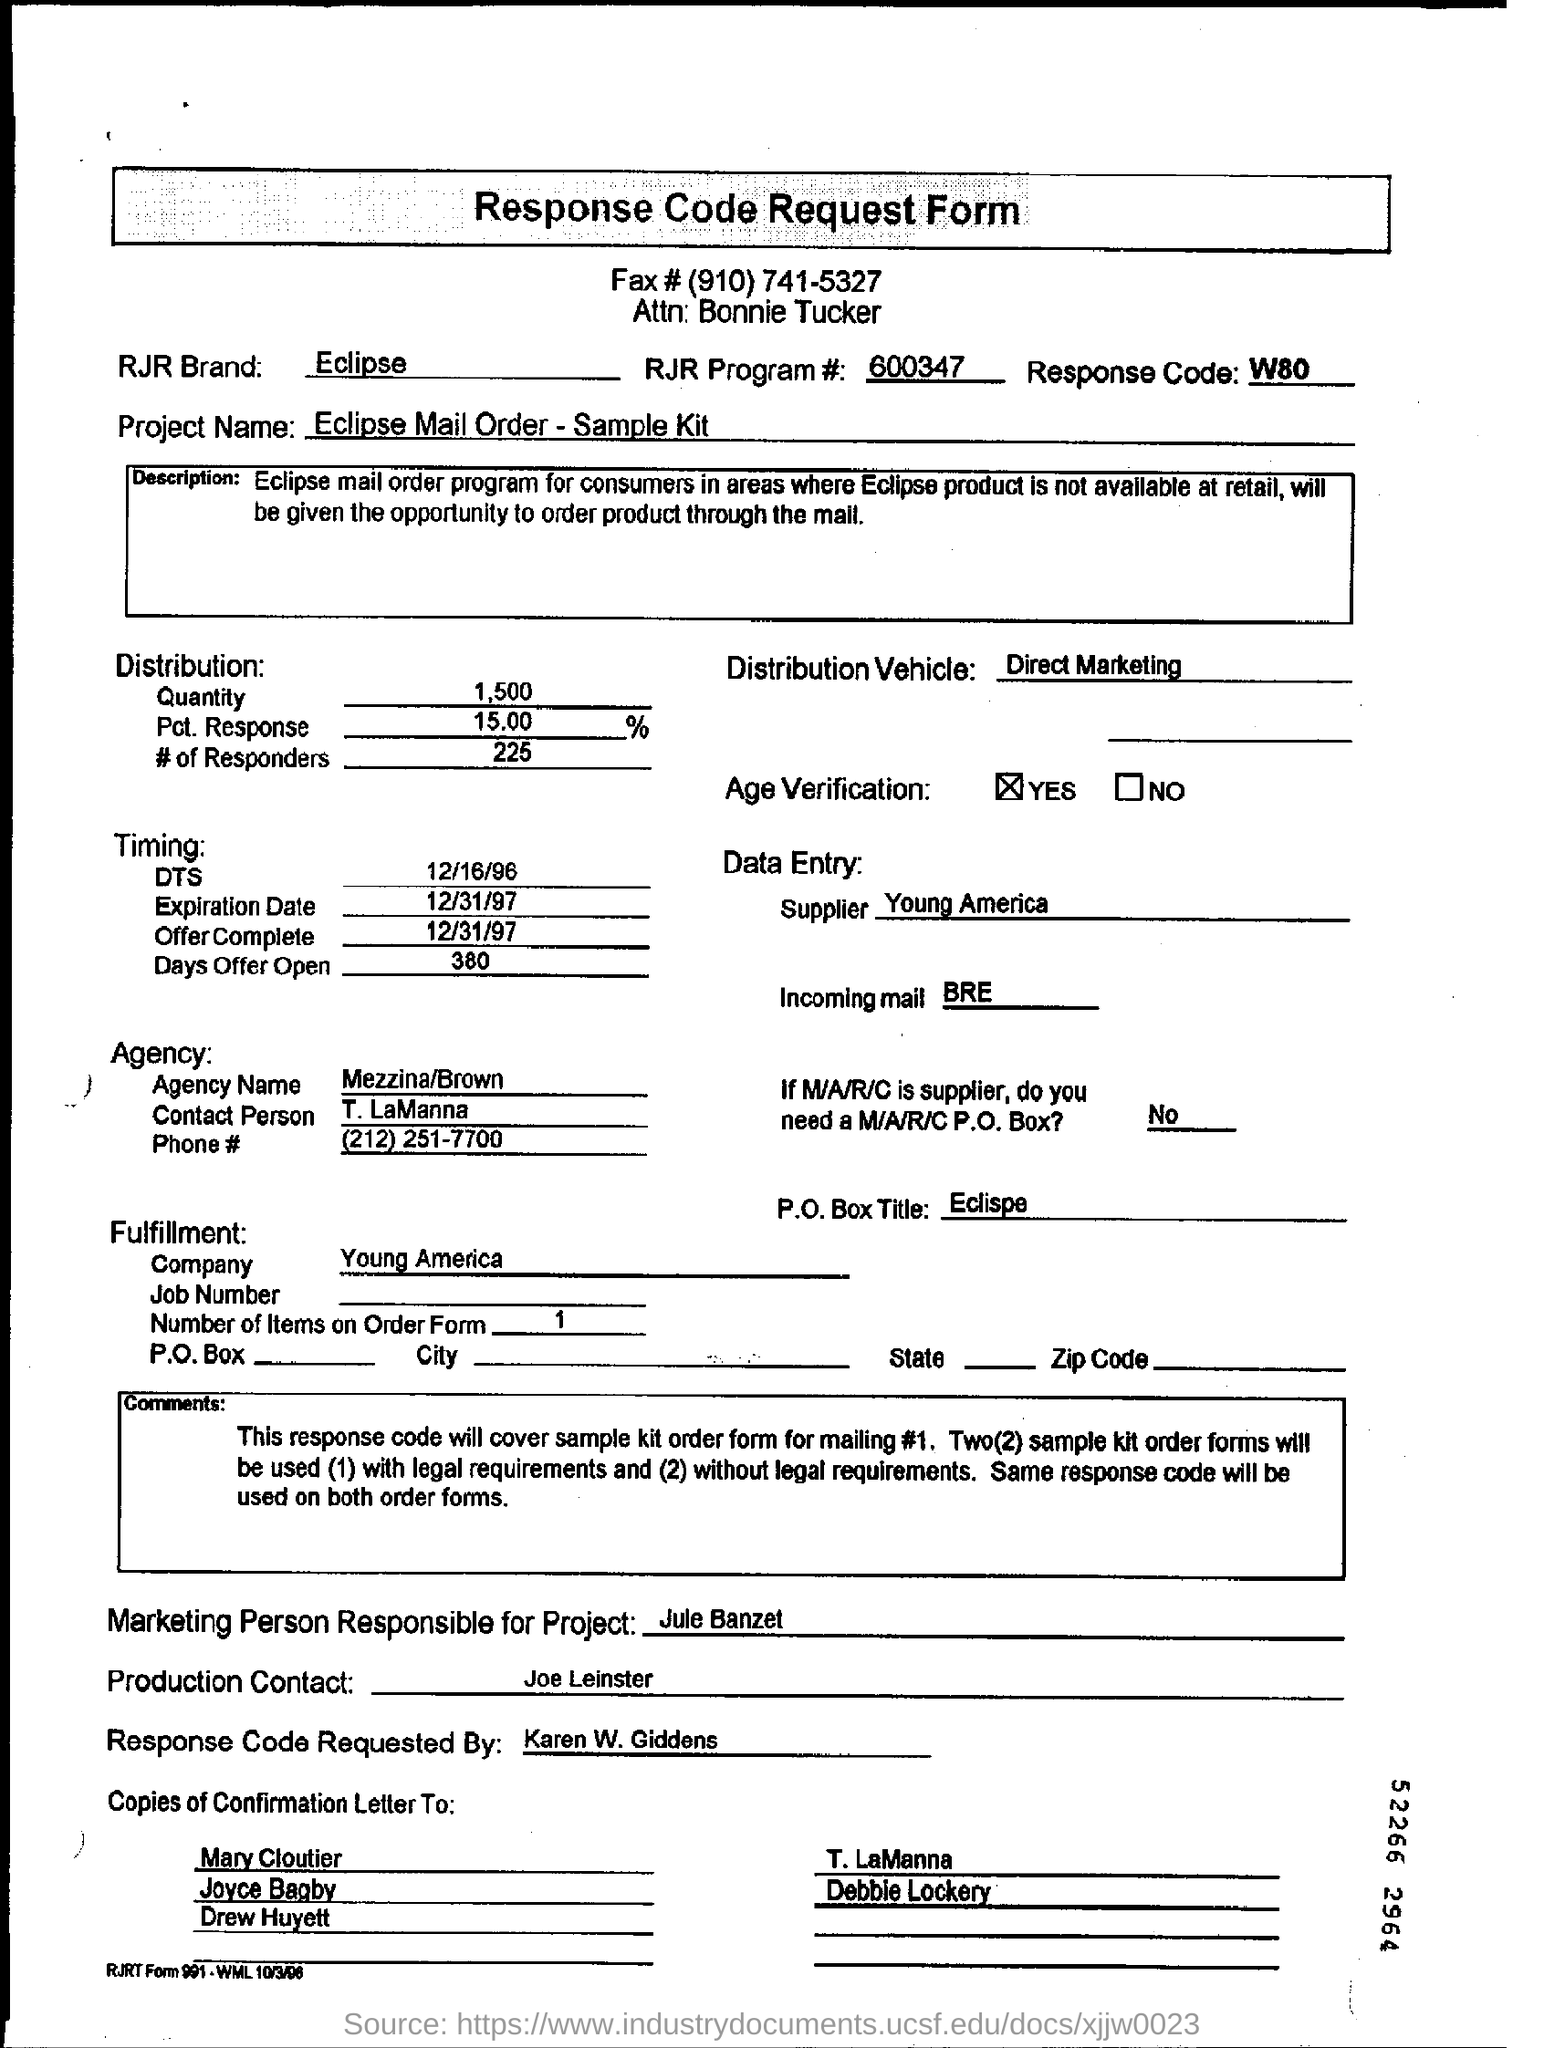Point out several critical features in this image. The RJR Brand mentioned is Eclipse. The supplier listed in the data entry is Young America. The project name mentioned is "Eclipse Mail Order-Sample Kit. 